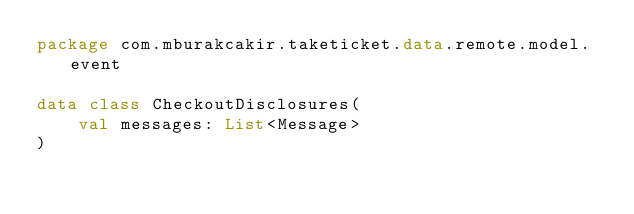Convert code to text. <code><loc_0><loc_0><loc_500><loc_500><_Kotlin_>package com.mburakcakir.taketicket.data.remote.model.event

data class CheckoutDisclosures(
    val messages: List<Message>
)</code> 